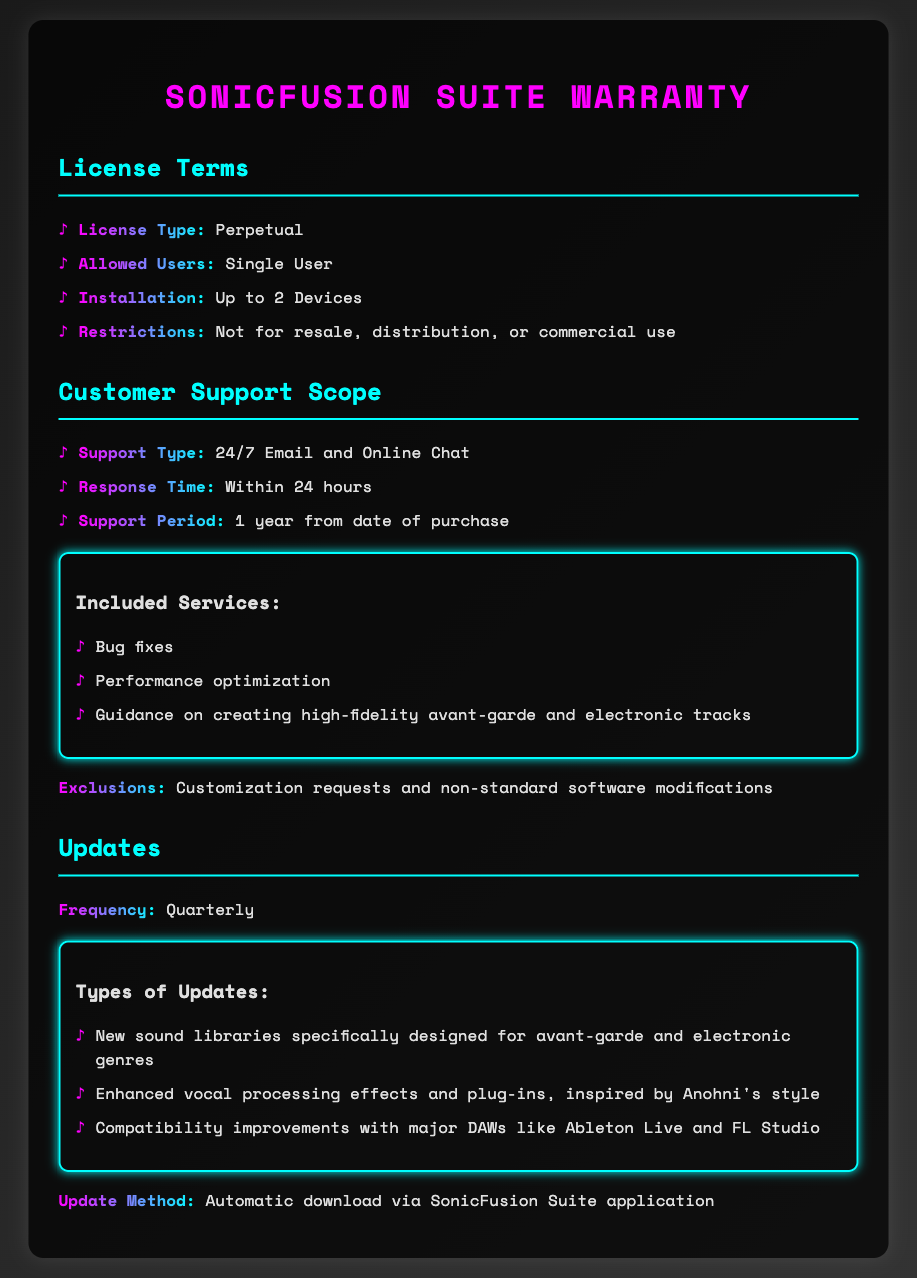What is the license type? The document states that the license type is described under the License Terms section as "Perpetual."
Answer: Perpetual How many devices can the software be installed on? According to the License Terms, the software can be installed on "Up to 2 Devices."
Answer: Up to 2 Devices What type of customer support is provided? In the Customer Support Scope section, it is mentioned that support is available via "24/7 Email and Online Chat."
Answer: 24/7 Email and Online Chat What is the response time for customer support? The Customer Support Scope indicates that the response time is "Within 24 hours."
Answer: Within 24 hours How frequently are updates released? The Updates section specifies that updates are released "Quarterly."
Answer: Quarterly What is one included service in the customer support? The document lists "Bug fixes" as one of the included services in support.
Answer: Bug fixes What type of updates are provided? The Updates section highlights "New sound libraries specifically designed for avant-garde and electronic genres."
Answer: New sound libraries specifically designed for avant-garde and electronic genres What is excluded from customer support? The Customer Support Scope mentions that "Customization requests and non-standard software modifications" are exclusions.
Answer: Customization requests and non-standard software modifications What inspiration is mentioned for the enhanced vocal processing effects? The Updates section states that these effects are inspired by "Anohni's style."
Answer: Anohni's style 